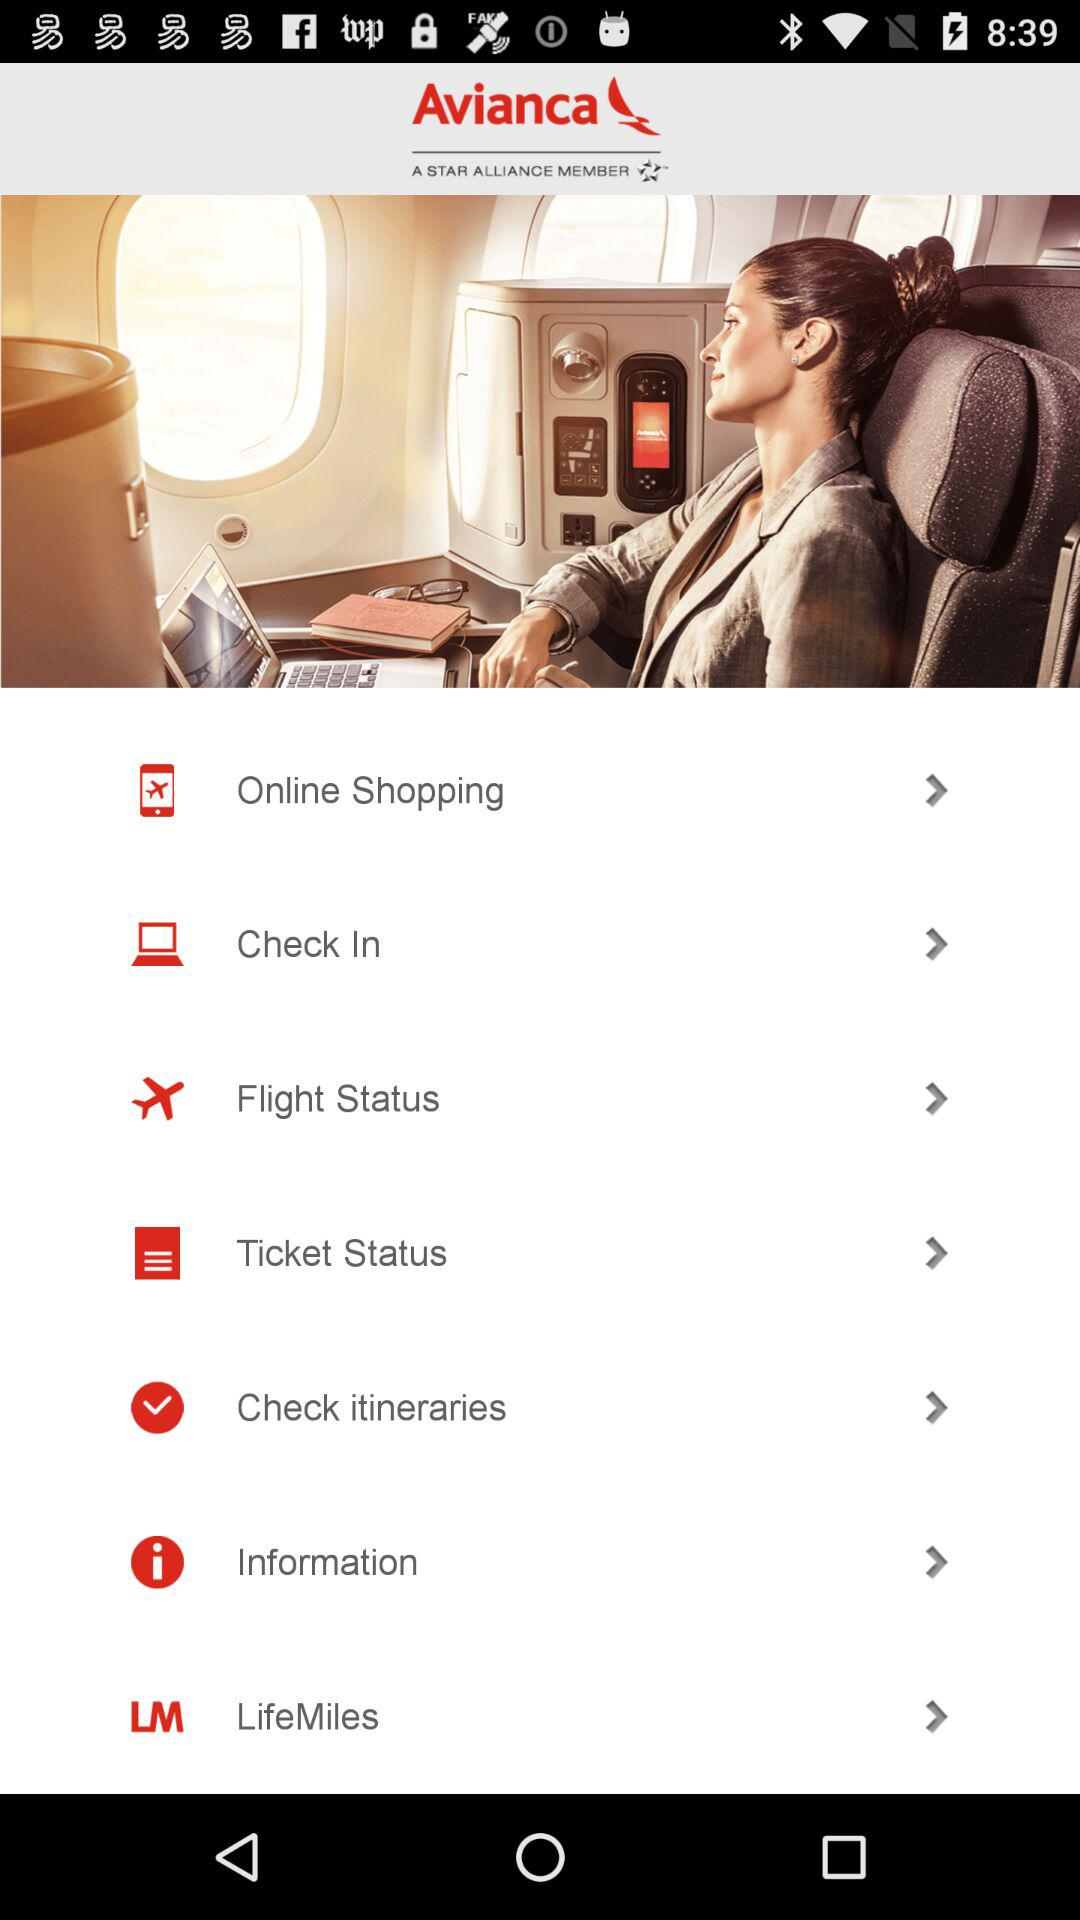What is the name of the application? The name of the application is "Avianca". 